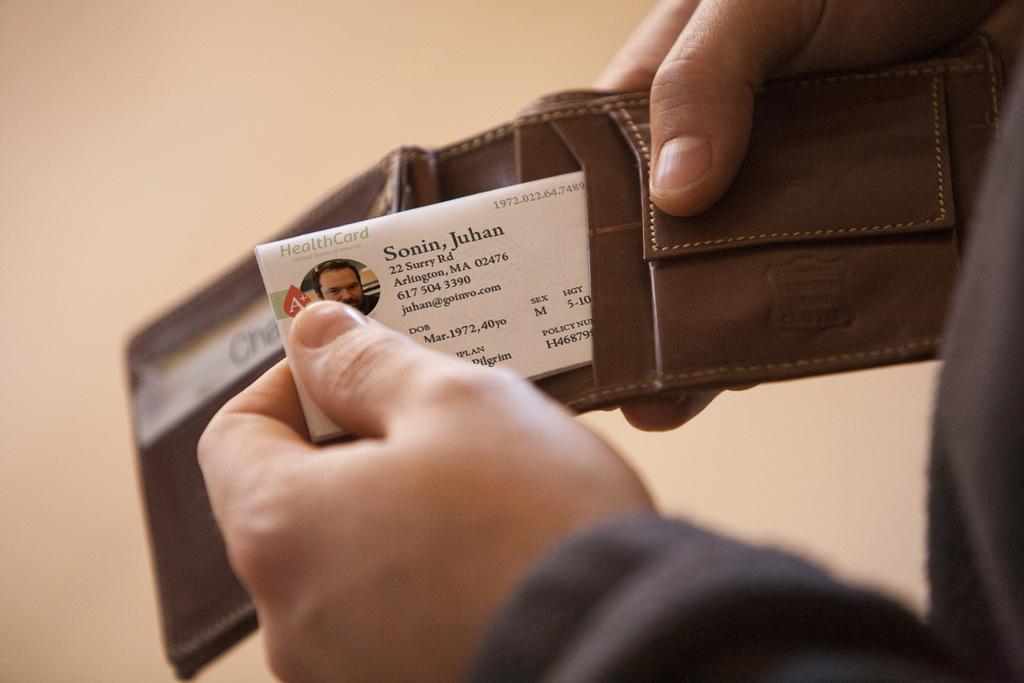In one or two sentences, can you explain what this image depicts? In this image we can see person's hands holding a wallet and a card. In the background there is a wall. 